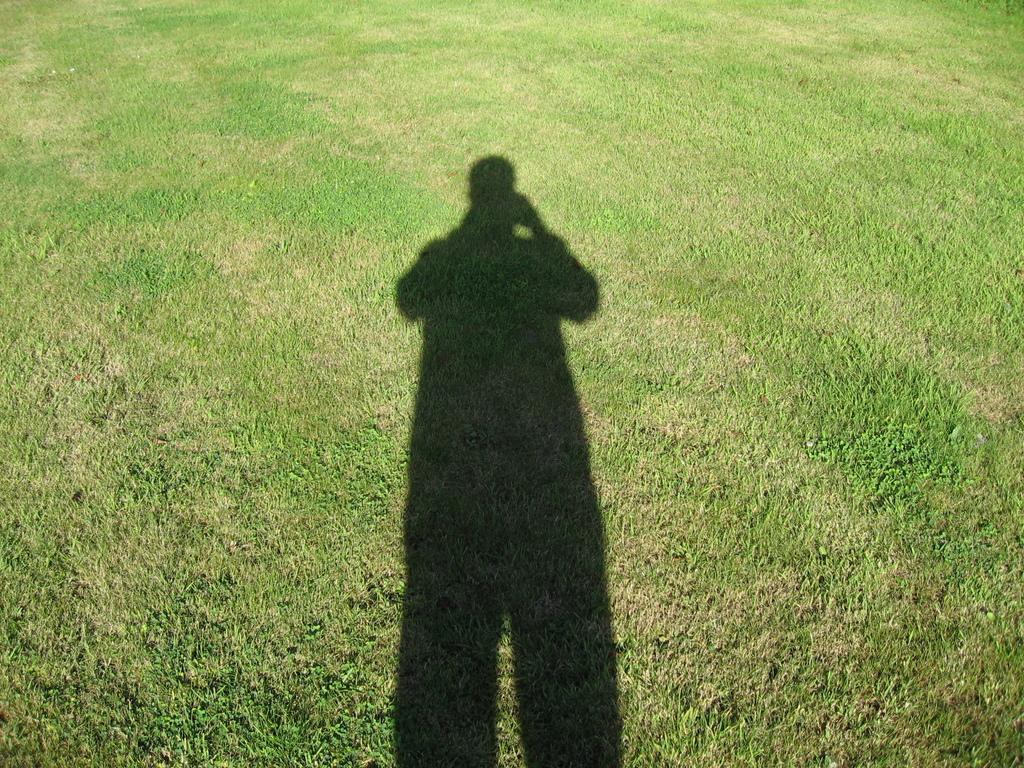In one or two sentences, can you explain what this image depicts? In this image I can see a person shadow and the grass is in green color. 